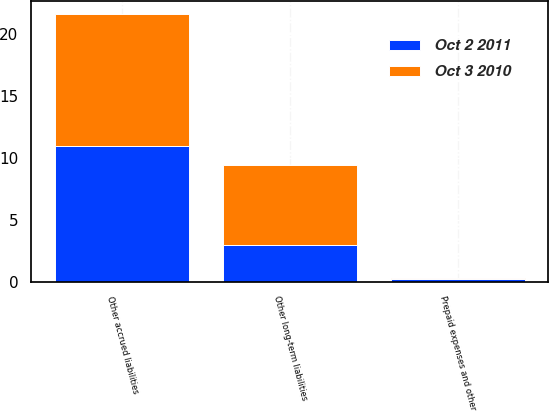<chart> <loc_0><loc_0><loc_500><loc_500><stacked_bar_chart><ecel><fcel>Prepaid expenses and other<fcel>Other accrued liabilities<fcel>Other long-term liabilities<nl><fcel>Oct 2 2011<fcel>0.2<fcel>11<fcel>3<nl><fcel>Oct 3 2010<fcel>0.1<fcel>10.6<fcel>6.4<nl></chart> 